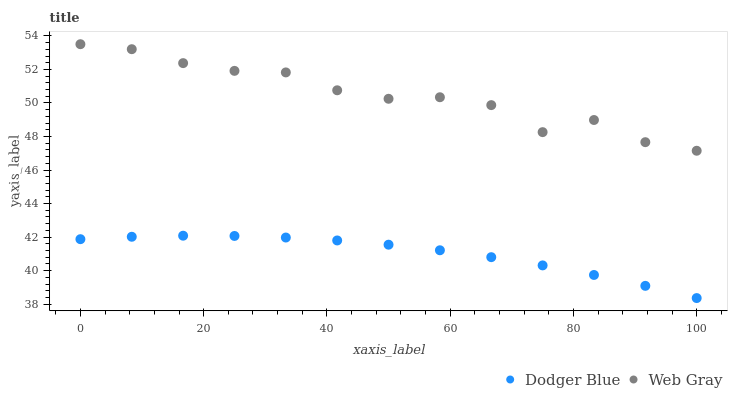Does Dodger Blue have the minimum area under the curve?
Answer yes or no. Yes. Does Web Gray have the maximum area under the curve?
Answer yes or no. Yes. Does Dodger Blue have the maximum area under the curve?
Answer yes or no. No. Is Dodger Blue the smoothest?
Answer yes or no. Yes. Is Web Gray the roughest?
Answer yes or no. Yes. Is Dodger Blue the roughest?
Answer yes or no. No. Does Dodger Blue have the lowest value?
Answer yes or no. Yes. Does Web Gray have the highest value?
Answer yes or no. Yes. Does Dodger Blue have the highest value?
Answer yes or no. No. Is Dodger Blue less than Web Gray?
Answer yes or no. Yes. Is Web Gray greater than Dodger Blue?
Answer yes or no. Yes. Does Dodger Blue intersect Web Gray?
Answer yes or no. No. 